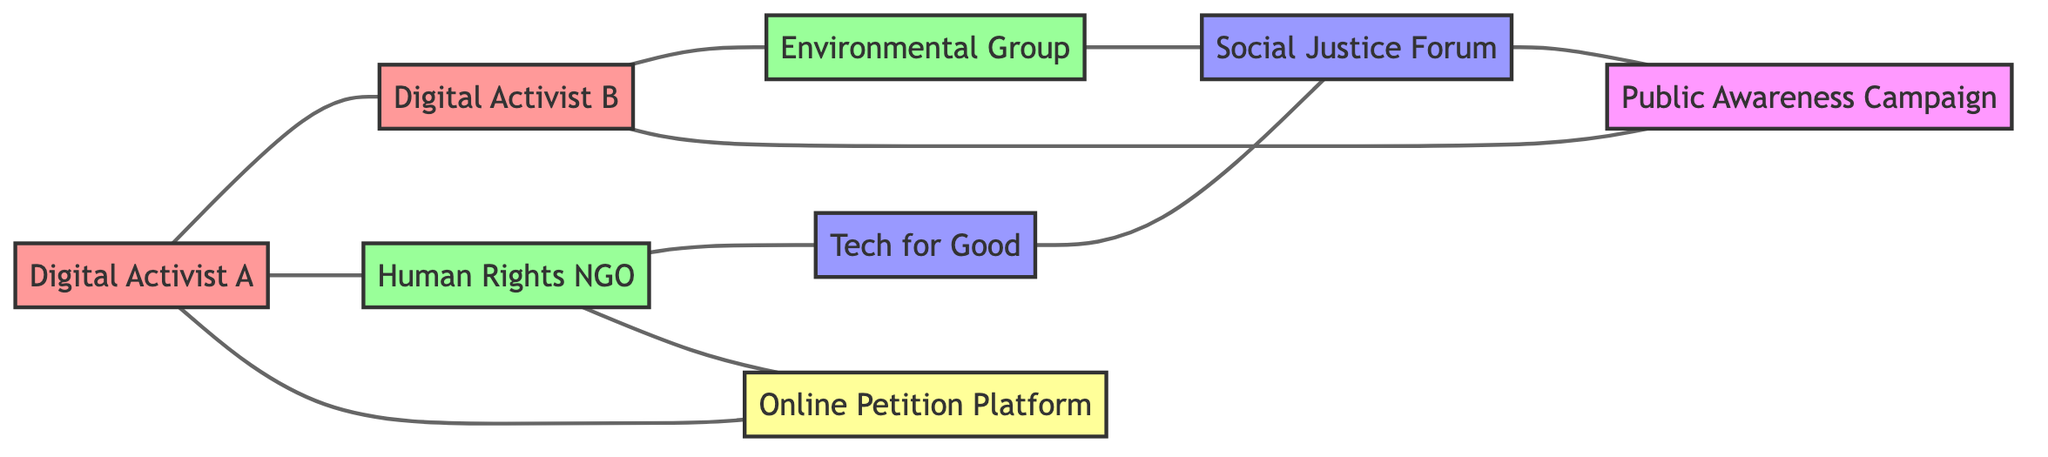What is the total number of nodes in the diagram? To find the total number of nodes, we count each unique node listed in the data. There are 8 nodes in total: Digital Activist A, Digital Activist B, Human Rights NGO, Environmental Group, Tech for Good, Social Justice Forum, Public Awareness Campaign, and Online Petition Platform.
Answer: 8 Which organization is affiliated with Tech for Good? We examine the connections in the diagram to determine which organization has a direct relationship with Tech for Good. The diagram shows that the Human Rights NGO is affiliated with Tech for Good.
Answer: Human Rights NGO How many collaborations does Digital Activist A have? We look at the edges connected to Digital Activist A and count each direct relationship. Digital Activist A collaborates with Digital Activist B and is partnered with Human Rights NGO, and promotes the Online Petition Platform. This totals to 3 collaborations.
Answer: 3 What initiative is organized by Social Justice Forum? We trace the connection from Social Justice Forum in the diagram to find out what initiative it organizes. The Social Justice Forum organizes the Public Awareness Campaign.
Answer: Public Awareness Campaign Which community does Digital Activist B participate in? We analyze the relationships associated with Digital Activist B, specifically looking at participation. The diagram shows that Digital Activist B participates in the Public Awareness Campaign.
Answer: Public Awareness Campaign How many nodes are connected to the Environmental Group? We examine the edges connected to the Environmental Group to see how many nodes it is linked to. The Environmental Group connects to Digital Activist B, Social Justice Forum, and indirectly influences Tech for Good and Public Awareness Campaign, totaling 3 direct relationships.
Answer: 3 Who promotes the Online Petition Platform? To find out who promotes the Online Petition Platform, we check the edges leading to this platform in the diagram. Digital Activist A is directly indicated as promoting the Online Petition Platform.
Answer: Digital Activist A Which nodes are described as "individual"? We identify the nodes in the diagram labeled as "individual" and count them. From the provided data, both Digital Activist A and Digital Activist B are the nodes classified under "individual."
Answer: Digital Activist A, Digital Activist B 